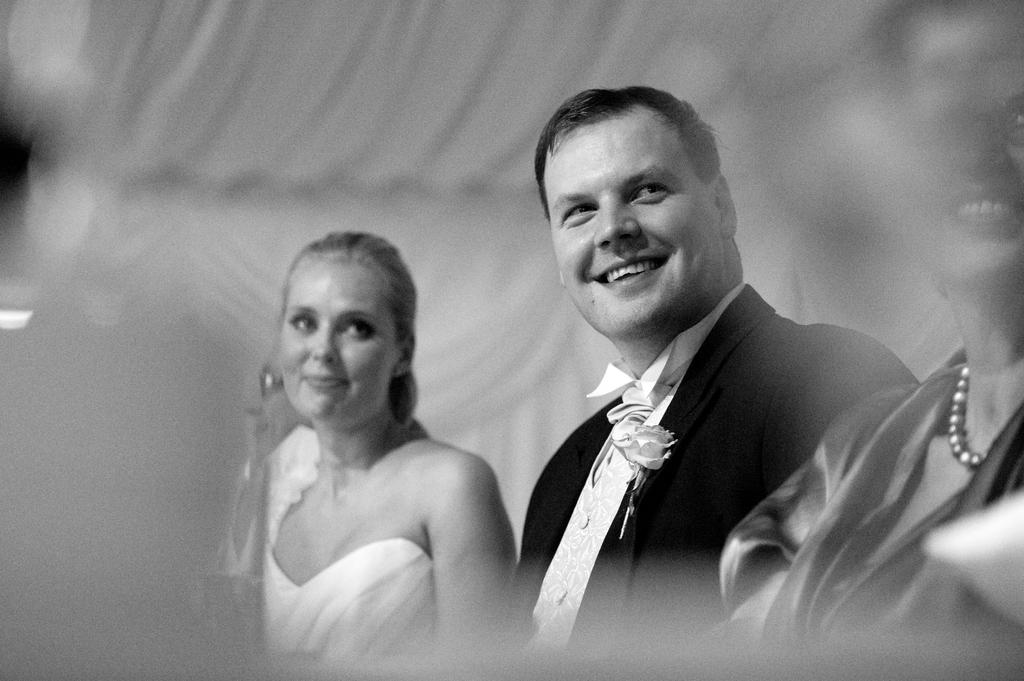How many people are in the image? There are persons in the image, but the exact number cannot be determined from the provided facts. What are the persons wearing in the image? The persons are wearing clothes in the image. What is the color scheme of the image? The image is black and white. Can you describe the background of the image? The background of the image is blurred. What type of furniture can be seen in the image? There is no furniture present in the image. Are there any bears visible in the image? There are no bears present in the image. 